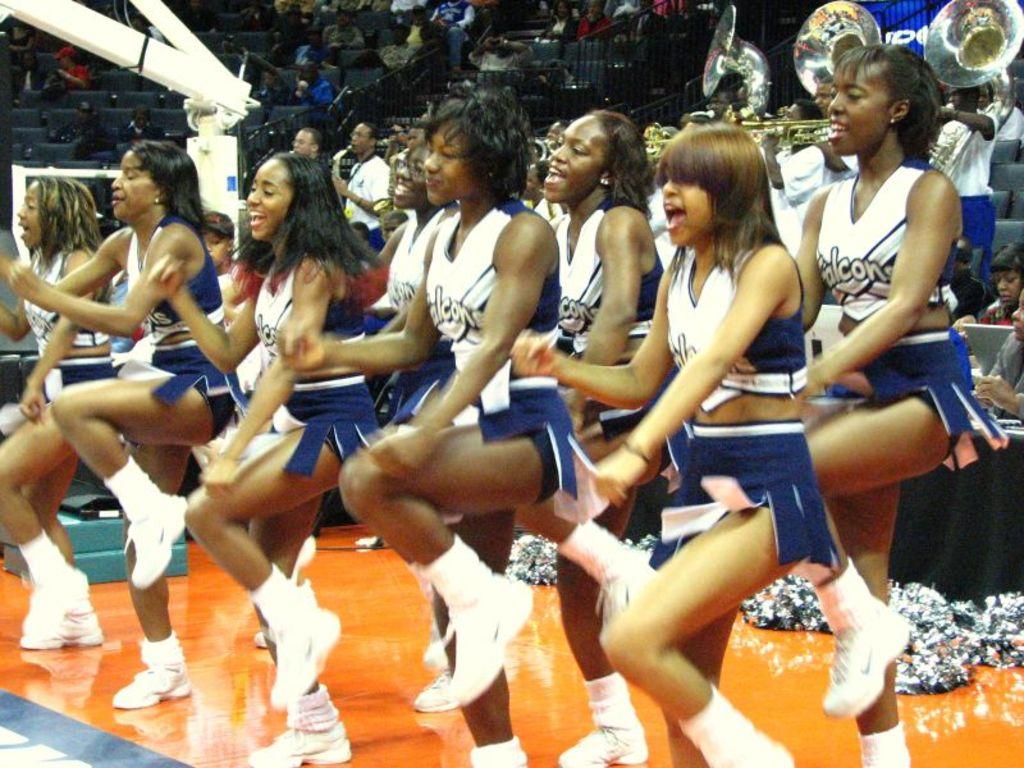What team are they cheering for?
Make the answer very short. Falcons. 